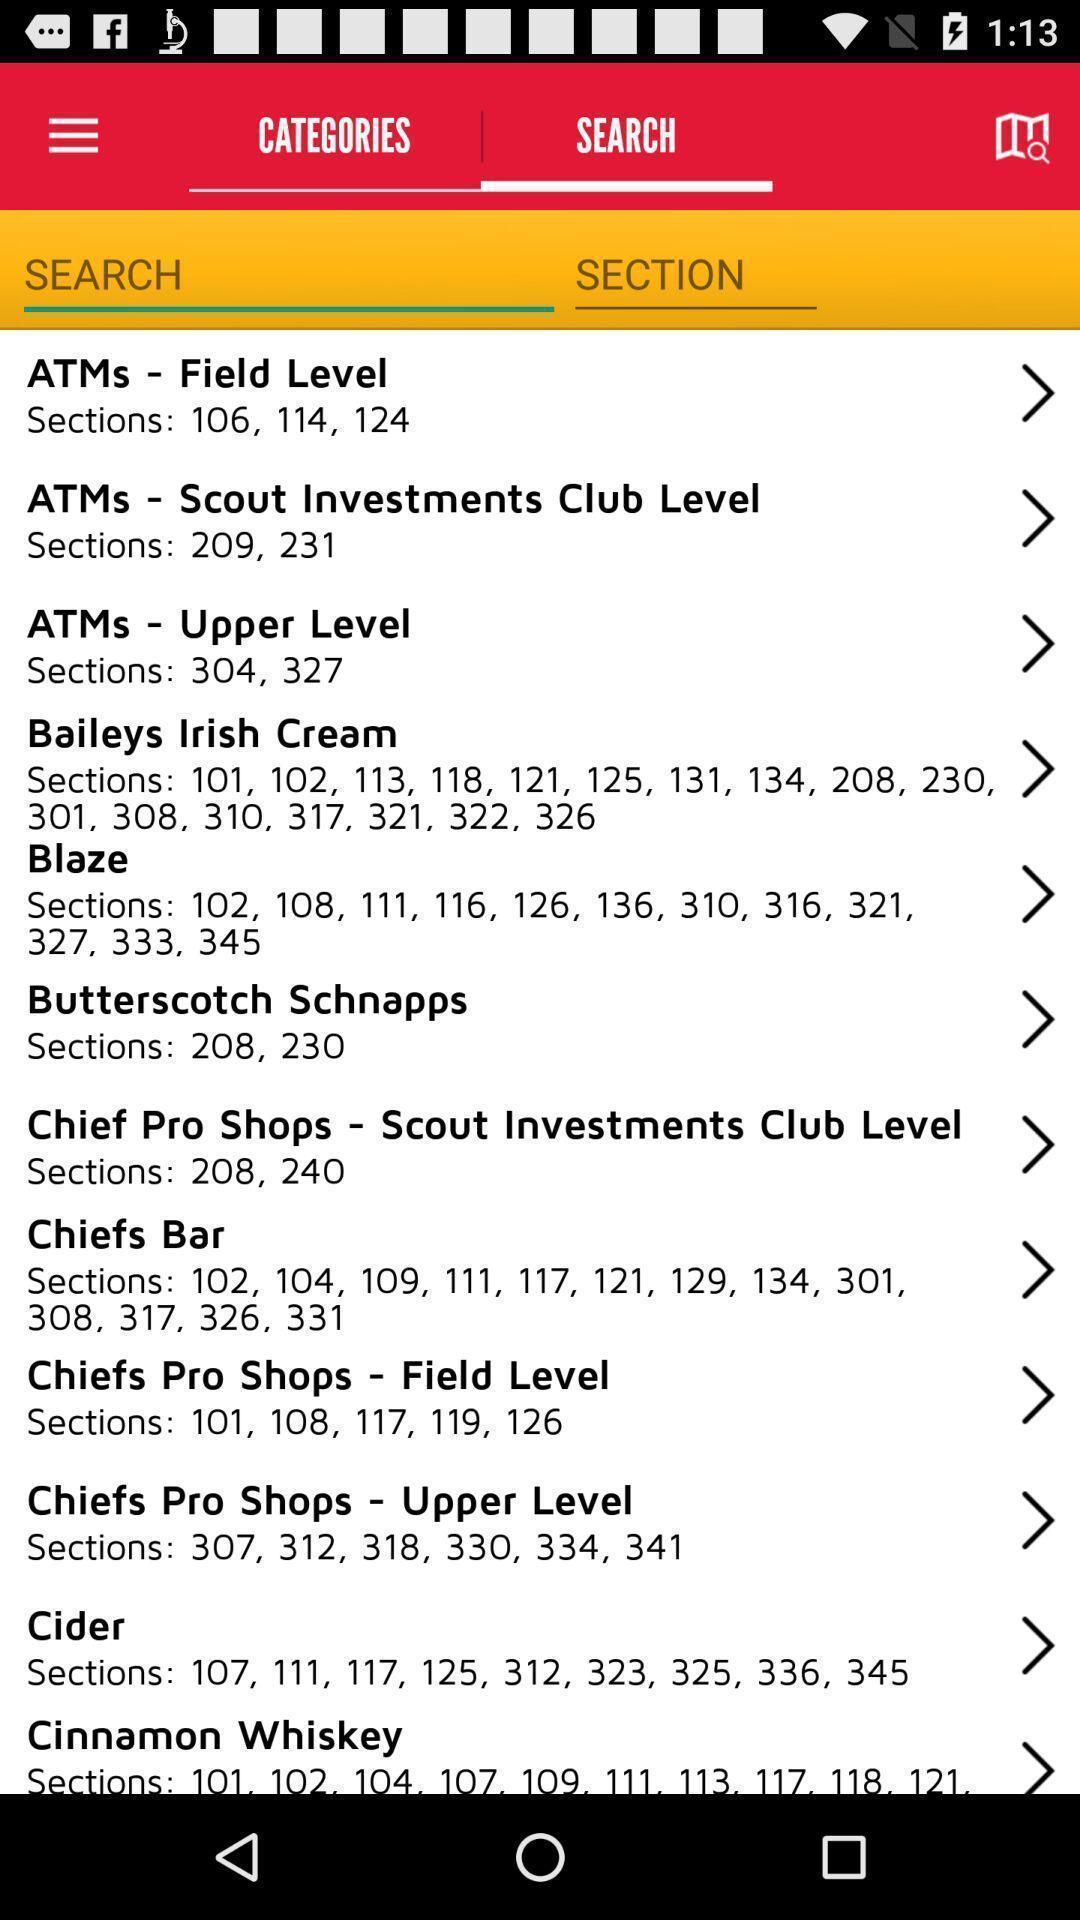Give me a narrative description of this picture. Page displays search results in app. 